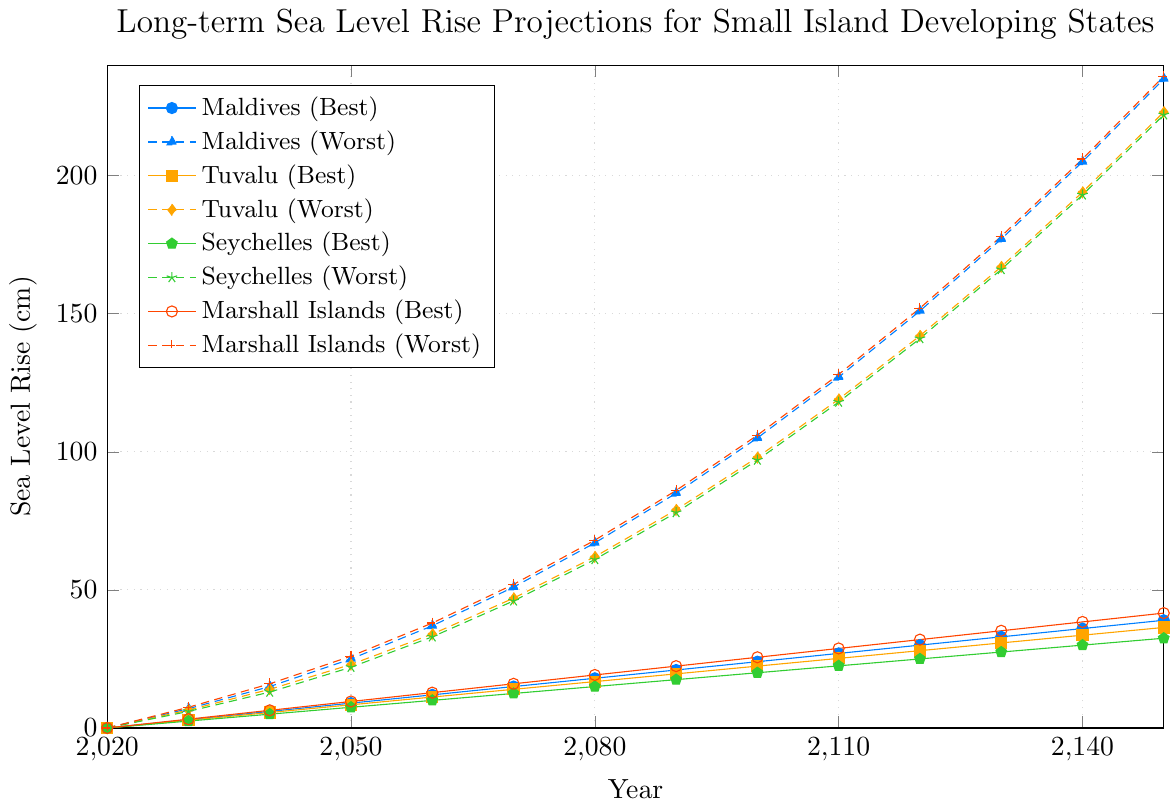What is the projected sea level rise for the Maldives in the worst-case scenario by 2070? Locate the worst-case scenario line for the Maldives and find the intersection with the year 2070. The value is 51 cm.
Answer: 51 cm Which island has the highest projected sea level rise in the best-case scenario by 2150, and what is the value? Compare the projected values in the best-case scenario for all islands at 2150. The plot for the Marshall Islands shows the highest value at 39 cm.
Answer: Marshall Islands, 39 cm In which year do the best-case and worst-case projections for the Seychelles diverge by 30 cm or more? Identify the years where the difference between the best-case and worst-case projections for the Seychelles exceeds 30 cm. By examining the plot, 2060 is the first year they diverge by this amount.
Answer: 2060 What is the average projected sea level rise for Tuvalu in the best-case scenario from 2040 to 2060? Sum the best-case values for Tuvalu from 2040 (5.6 cm), 2050 (8.4 cm), and 2060 (11.2 cm) and then divide by 3. \((5.6+8.4+11.2)/3 = 8.4 \text{ cm}\)
Answer: 8.4 cm Which location shows a greater increase in sea level from 2100 to 2150 under the worst-case scenario: the Maldives or the Marshall Islands? Calculate the difference between the projected values for 2100 and 2150 for the worst-case scenarios. For the Maldives: \(235 - 105 = 130 \text{ cm}\). For the Marshall Islands: \(236 - 106 = 130 \text{ cm}\). Both show a 130 cm increase.
Answer: Both increase by 130 cm At what year does the worst-case scenario projection for Tuvalu reach 100 cm? Find the year where the worst-case scenario projection line for Tuvalu intersects the 100 cm mark. This occurs just after the year 2100.
Answer: Shortly after 2100 Compare the rise in sea level for the Marshall Islands between the years 2130 and 2150 under both scenarios. How much more does it rise under the worst-case scenario compared to the best-case scenario? For the worst-case: \(236 - 178 = 58 \text{ cm}\). For the best-case: \(41.6 - 35.2 = 6.4 \text{ cm}\). Difference: \(58 - 6.4 = 51.6 \text{ cm}\)
Answer: 51.6 cm Which island has the lowest projected sea level rise in the worst-case scenario by 2140, and what is the value? Compare the worst-case scenario projections for all islands at 2140. Seychelles shows the lowest value at 193 cm.
Answer: Seychelles, 193 cm 